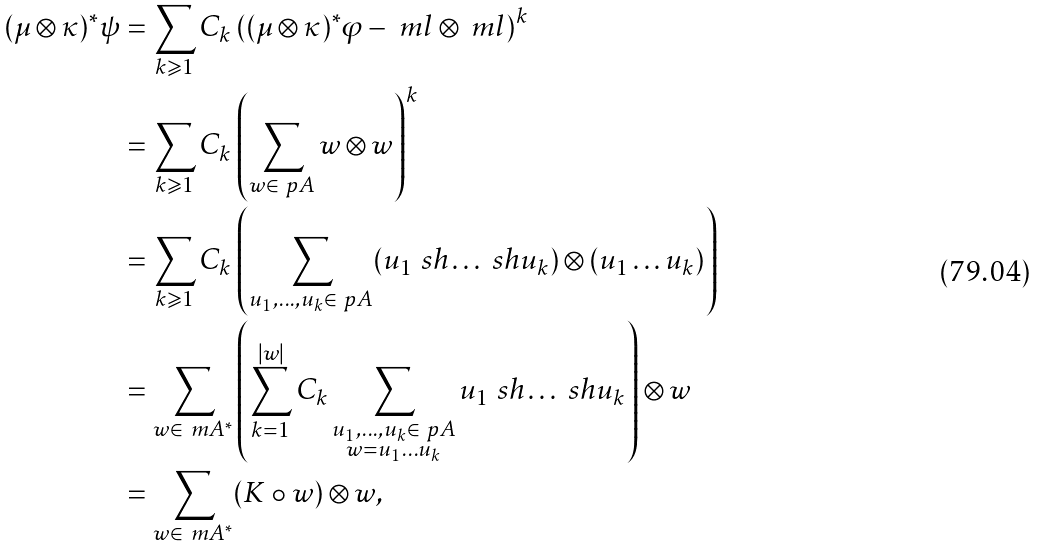<formula> <loc_0><loc_0><loc_500><loc_500>( \mu \otimes \kappa ) ^ { * } \psi = & \, \sum _ { k \geqslant 1 } C _ { k } \left ( ( \mu \otimes \kappa ) ^ { * } \varphi - \ m l \otimes \ m l \right ) ^ { k } \\ = & \, \sum _ { k \geqslant 1 } C _ { k } \left ( \sum _ { w \in \ p A } w \otimes w \right ) ^ { k } \\ = & \, \sum _ { k \geqslant 1 } C _ { k } \left ( \sum _ { u _ { 1 } , \dots , u _ { k } \in \ p A } ( u _ { 1 } \ s h \dots \ s h u _ { k } ) \otimes ( u _ { 1 } \dots u _ { k } ) \right ) \\ = & \, \sum _ { w \in \ m A ^ { * } } \left ( \sum _ { k = 1 } ^ { | w | } C _ { k } \sum _ { \substack { u _ { 1 } , \dots , u _ { k } \in \ p A \\ w = u _ { 1 } \dots u _ { k } } } u _ { 1 } \ s h \dots \ s h u _ { k } \right ) \otimes w \\ = & \, \sum _ { w \in \ m A ^ { * } } ( K \circ w ) \otimes w ,</formula> 